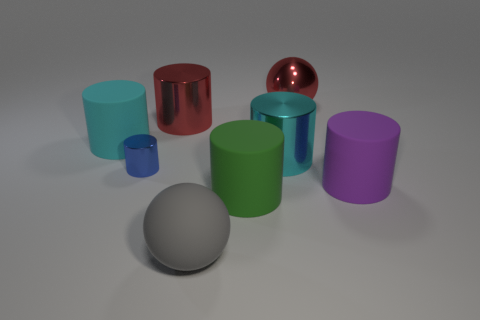Do the red cylinder and the sphere behind the big cyan rubber cylinder have the same size?
Ensure brevity in your answer.  Yes. What number of gray rubber objects have the same size as the purple object?
Give a very brief answer. 1. There is a large sphere that is made of the same material as the small cylinder; what is its color?
Keep it short and to the point. Red. Are there more big green things than metal cylinders?
Make the answer very short. No. Does the red cylinder have the same material as the tiny cylinder?
Provide a succinct answer. Yes. There is a green thing that is made of the same material as the big gray ball; what is its shape?
Provide a short and direct response. Cylinder. Is the number of green rubber things less than the number of large red metallic objects?
Your answer should be very brief. Yes. There is a cylinder that is both on the left side of the big green cylinder and to the right of the tiny metal thing; what is its material?
Keep it short and to the point. Metal. There is a red metallic thing to the right of the cyan thing in front of the big matte cylinder that is behind the large purple cylinder; how big is it?
Ensure brevity in your answer.  Large. There is a blue metallic thing; is its shape the same as the large red thing on the right side of the large red metal cylinder?
Your response must be concise. No. 